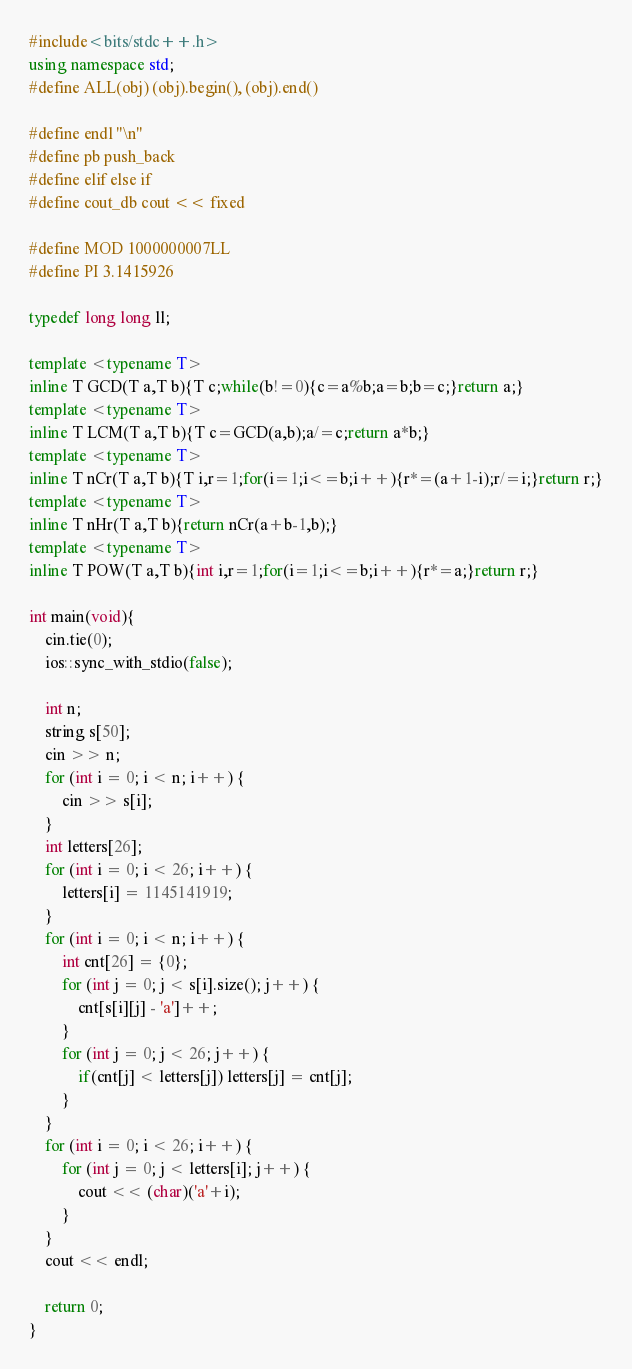Convert code to text. <code><loc_0><loc_0><loc_500><loc_500><_C++_>#include<bits/stdc++.h>
using namespace std;
#define ALL(obj) (obj).begin(), (obj).end()

#define endl "\n"
#define pb push_back
#define elif else if
#define cout_db cout << fixed

#define MOD 1000000007LL
#define PI 3.1415926

typedef long long ll;

template <typename T>
inline T GCD(T a,T b){T c;while(b!=0){c=a%b;a=b;b=c;}return a;}
template <typename T>
inline T LCM(T a,T b){T c=GCD(a,b);a/=c;return a*b;}
template <typename T>
inline T nCr(T a,T b){T i,r=1;for(i=1;i<=b;i++){r*=(a+1-i);r/=i;}return r;}
template <typename T>
inline T nHr(T a,T b){return nCr(a+b-1,b);}
template <typename T>
inline T POW(T a,T b){int i,r=1;for(i=1;i<=b;i++){r*=a;}return r;}

int main(void){
	cin.tie(0);
	ios::sync_with_stdio(false);

	int n;
	string s[50];
	cin >> n;
	for (int i = 0; i < n; i++) {
		cin >> s[i];
	}
	int letters[26];
	for (int i = 0; i < 26; i++) {
		letters[i] = 1145141919;
	}
	for (int i = 0; i < n; i++) {
		int cnt[26] = {0};
		for (int j = 0; j < s[i].size(); j++) {
			cnt[s[i][j] - 'a']++;
		}
		for (int j = 0; j < 26; j++) {
			if(cnt[j] < letters[j]) letters[j] = cnt[j];
		}
	}
	for (int i = 0; i < 26; i++) {
		for (int j = 0; j < letters[i]; j++) {
			cout << (char)('a'+i);
		}
	}
	cout << endl;

	return 0;
}</code> 